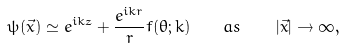Convert formula to latex. <formula><loc_0><loc_0><loc_500><loc_500>\psi ( \vec { x } ) \simeq e ^ { i k z } + \frac { e ^ { i k r } } { r } f ( \theta ; k ) \quad a s \quad \left | \vec { x } \right | \to \infty ,</formula> 